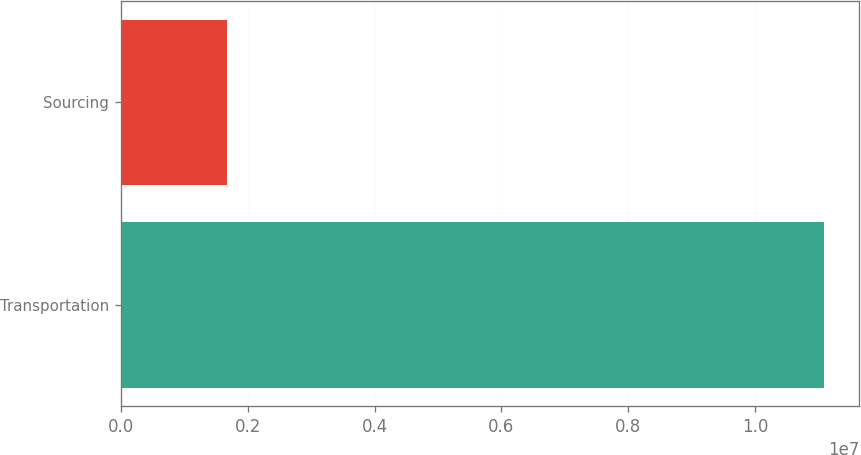Convert chart to OTSL. <chart><loc_0><loc_0><loc_500><loc_500><bar_chart><fcel>Transportation<fcel>Sourcing<nl><fcel>1.10829e+07<fcel>1.66913e+06<nl></chart> 